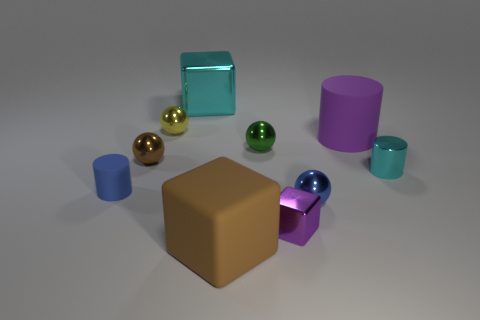The tiny cylinder to the right of the purple object that is left of the blue metallic sphere is what color? The small cylinder situated to the right of the purple object, which itself is positioned to the left of the lustrous blue sphere, exhibits a cyan hue. 